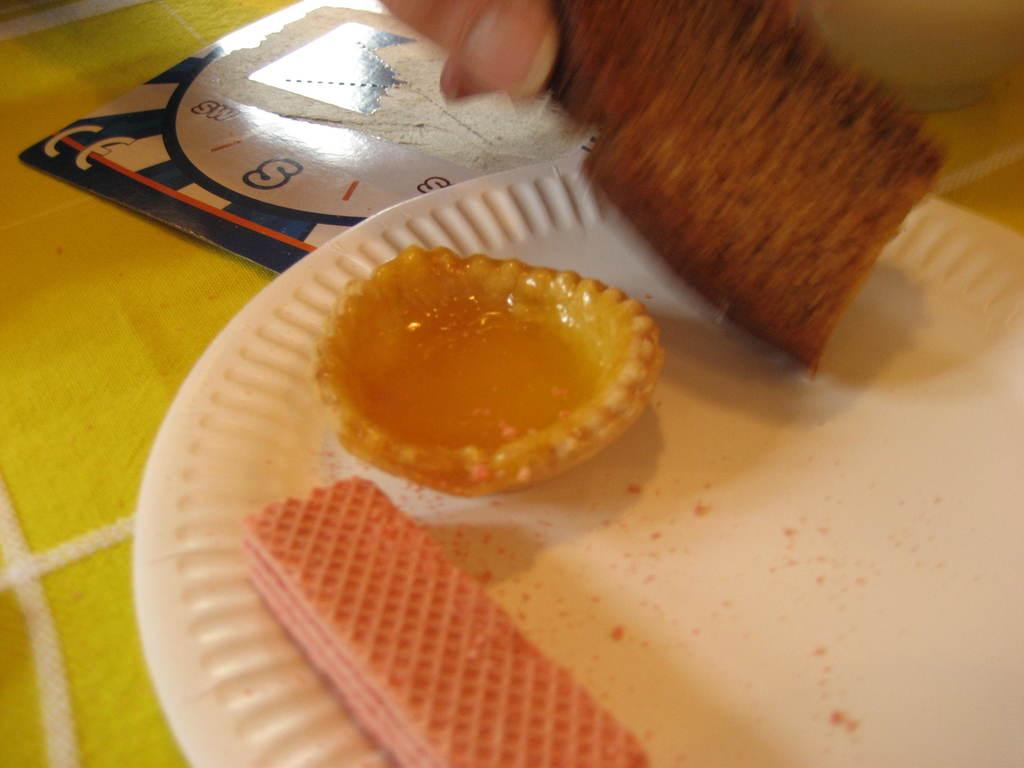What is present on the plate in the image? There is no information about what is on the plate in the image. What is present in the bowl in the image? There is no information about what is in the bowl in the image. What type of food can be seen in the image? Biscuits and bread can be seen in the image. Whose hand is visible in the image? A person's hand is visible in the image. Where might the image have been taken? The image is likely taken in a room, as there is no indication of an outdoor setting. How does the wind affect the biscuits in the image? There is no wind present in the image, as it is likely taken indoors. What type of destruction can be seen in the image? There is no destruction present in the image; it appears to be a normal scene with biscuits, bread, and a person's hand. 